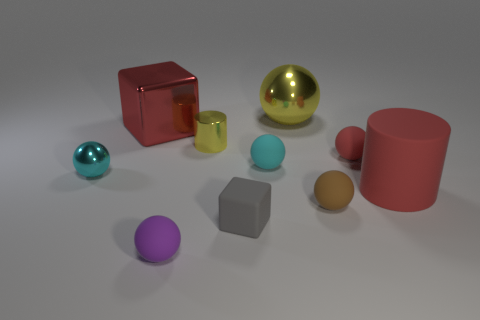Subtract all tiny brown balls. How many balls are left? 5 Subtract all cyan cylinders. How many cyan spheres are left? 2 Subtract all brown balls. How many balls are left? 5 Subtract 4 balls. How many balls are left? 2 Subtract all cylinders. How many objects are left? 8 Subtract all gray spheres. Subtract all gray cylinders. How many spheres are left? 6 Add 2 rubber blocks. How many rubber blocks exist? 3 Subtract 0 green cylinders. How many objects are left? 10 Subtract all small red shiny cylinders. Subtract all red things. How many objects are left? 7 Add 9 small yellow metal objects. How many small yellow metal objects are left? 10 